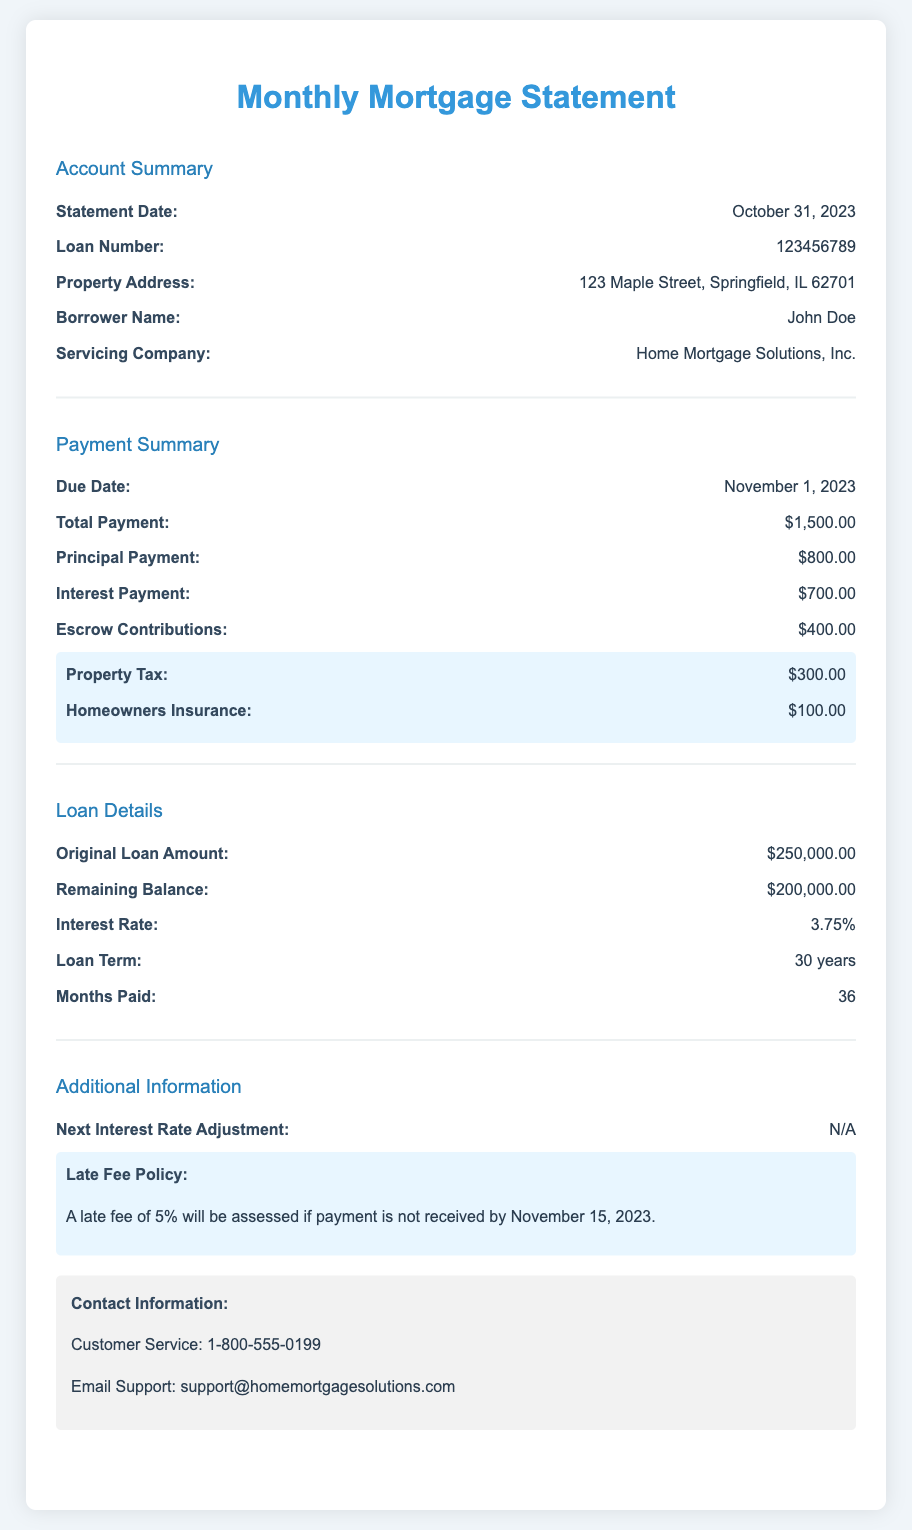What is the statement date? The statement date refers to the date when the mortgage statement is issued, which is October 31, 2023.
Answer: October 31, 2023 What is the total payment due? The total payment due is the amount that needs to be paid for the month, which is specified in the document as $1,500.00.
Answer: $1,500.00 What is the principal payment amount? The principal payment is the portion of the total payment that goes towards paying off the loan's principal balance, listed as $800.00.
Answer: $800.00 What is the interest payment amount? The interest payment is the portion of the total payment that goes towards interest on the loan, stated as $700.00.
Answer: $700.00 What is the remaining balance of the loan? The remaining balance indicates how much is left to pay on the original loan amount, which is reported as $200,000.00.
Answer: $200,000.00 What is the interest rate on this loan? The interest rate is the percentage that the loan accrues interest at, which is recorded as 3.75%.
Answer: 3.75% What is the due date for the next payment? The due date for the next payment indicates when the next payment is due, which is mentioned as November 1, 2023.
Answer: November 1, 2023 What late fee will be assessed if payment is late? The document specifies that a 5% late fee will be assessed if payment is not received by November 15, 2023.
Answer: 5% What is the term of the loan? The loan term represents the duration over which the loan is to be repaid, which is a period of 30 years as noted in the document.
Answer: 30 years Who is the servicing company? The servicing company is the entity responsible for managing the loan, which is identified as Home Mortgage Solutions, Inc.
Answer: Home Mortgage Solutions, Inc 